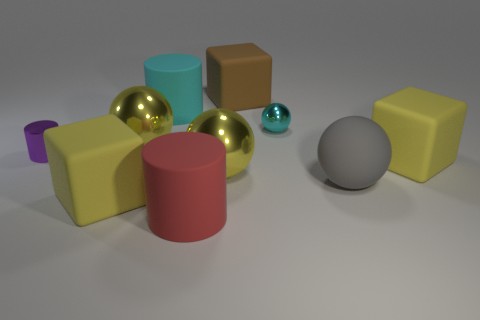Subtract all large gray matte spheres. How many spheres are left? 3 Subtract 1 balls. How many balls are left? 3 Subtract all yellow cubes. How many cubes are left? 1 Subtract all purple cubes. How many purple cylinders are left? 1 Subtract all blocks. How many objects are left? 7 Subtract all large yellow things. Subtract all big matte cylinders. How many objects are left? 4 Add 3 large balls. How many large balls are left? 6 Add 7 cubes. How many cubes exist? 10 Subtract 2 yellow cubes. How many objects are left? 8 Subtract all green spheres. Subtract all yellow cubes. How many spheres are left? 4 